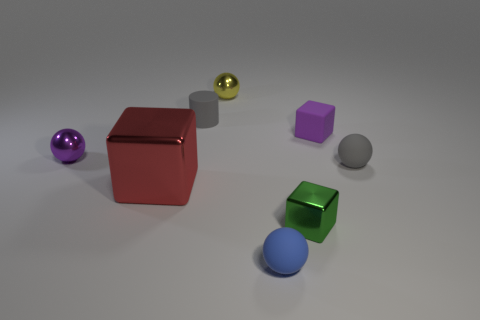Subtract all small blocks. How many blocks are left? 1 Subtract 1 red blocks. How many objects are left? 7 Subtract all blocks. How many objects are left? 5 Subtract 1 cubes. How many cubes are left? 2 Subtract all purple balls. Subtract all red blocks. How many balls are left? 3 Subtract all purple balls. How many purple cylinders are left? 0 Subtract all big blue shiny balls. Subtract all green shiny things. How many objects are left? 7 Add 3 yellow things. How many yellow things are left? 4 Add 3 small green things. How many small green things exist? 4 Add 1 small objects. How many objects exist? 9 